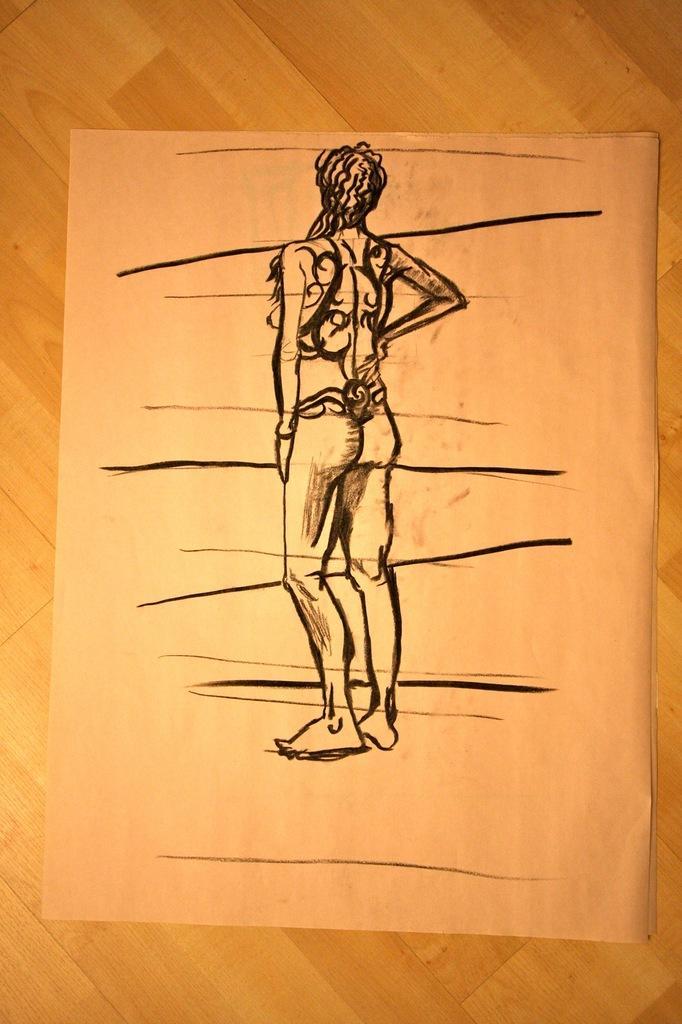Please provide a concise description of this image. In the image there is a sketch of a person on a paper. 